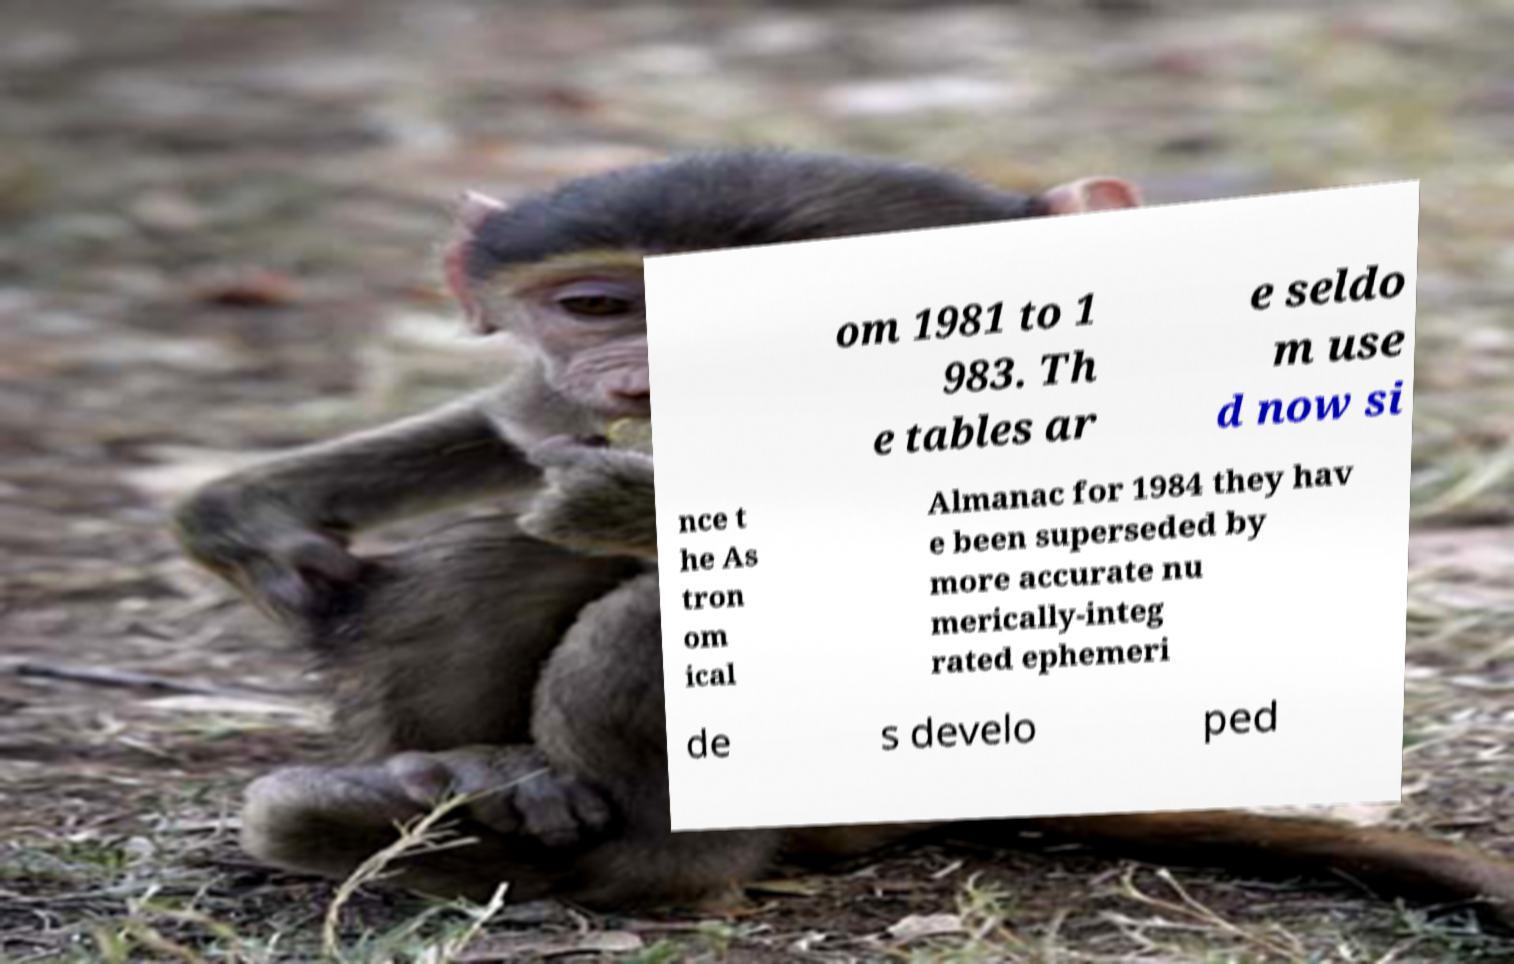Can you read and provide the text displayed in the image?This photo seems to have some interesting text. Can you extract and type it out for me? om 1981 to 1 983. Th e tables ar e seldo m use d now si nce t he As tron om ical Almanac for 1984 they hav e been superseded by more accurate nu merically-integ rated ephemeri de s develo ped 